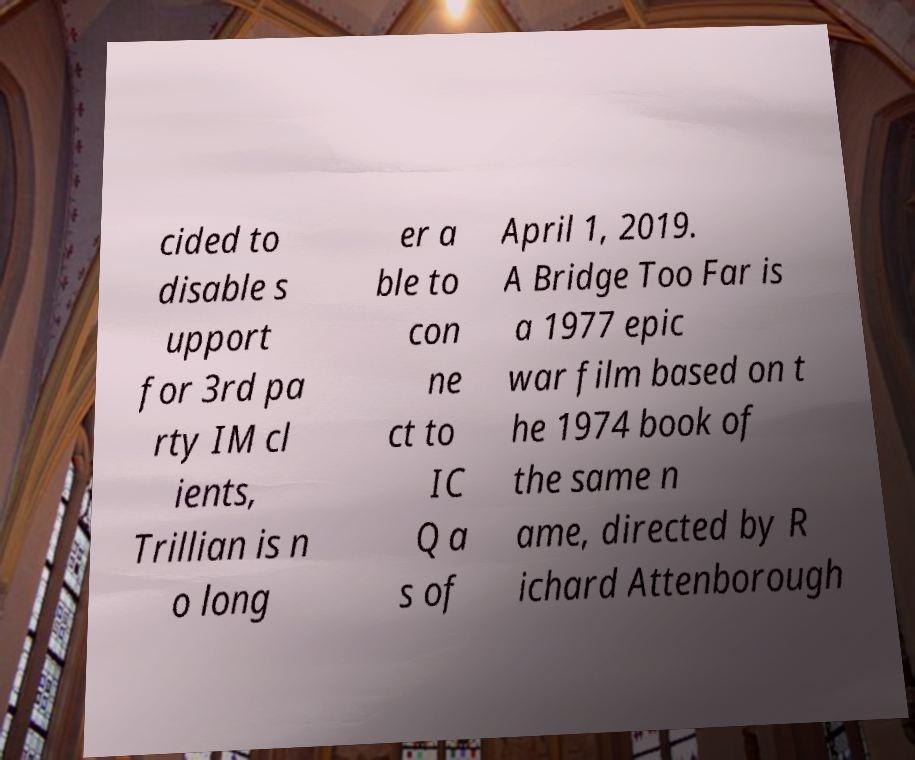Could you assist in decoding the text presented in this image and type it out clearly? cided to disable s upport for 3rd pa rty IM cl ients, Trillian is n o long er a ble to con ne ct to IC Q a s of April 1, 2019. A Bridge Too Far is a 1977 epic war film based on t he 1974 book of the same n ame, directed by R ichard Attenborough 